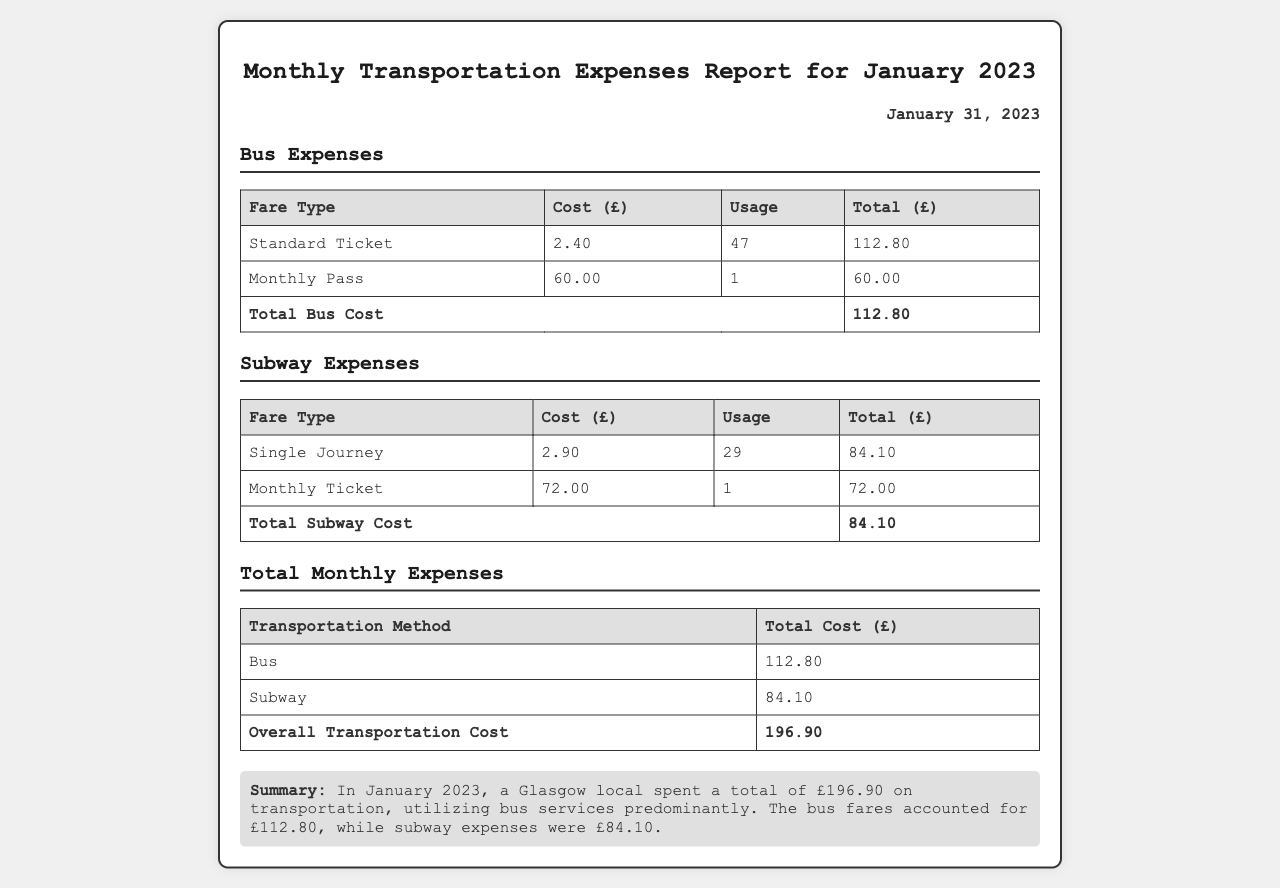What is the total bus cost? The total bus cost is listed in the Bus Expenses section, which sums up to £112.80.
Answer: £112.80 How many single journeys were used? The number of single journeys is found in the Subway Expenses section, which indicates 29 usages.
Answer: 29 What is the cost of a monthly pass? The cost of a Monthly Pass is specified as £60.00 in the Bus Expenses table.
Answer: £60.00 What is the total monthly transportation cost? The overall transportation cost is detailed in the Total Monthly Expenses, calculating to £196.90.
Answer: £196.90 How much was spent on subway tickets? The total spent on subway tickets is presented in the Subway Expenses section, totalling £84.10.
Answer: £84.10 What fare type was used most for buses? The fare type used most for buses is the Standard Ticket, with 47 usages compared to the Monthly Pass.
Answer: Standard Ticket What is the cost of a single journey? The cost of a single journey is listed in the Subway Expenses as £2.90.
Answer: £2.90 How many monthly subway tickets were purchased? The number of monthly subway tickets purchased is shown in the Subway Expenses section, which is 1.
Answer: 1 What date was the report generated? The report date can be found prominently in the document, stating January 31, 2023.
Answer: January 31, 2023 